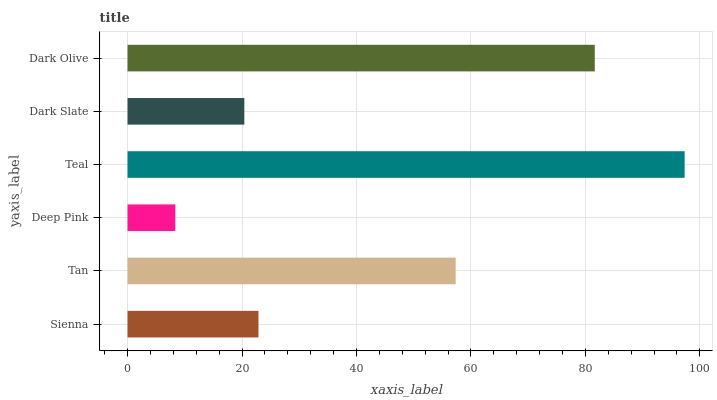Is Deep Pink the minimum?
Answer yes or no. Yes. Is Teal the maximum?
Answer yes or no. Yes. Is Tan the minimum?
Answer yes or no. No. Is Tan the maximum?
Answer yes or no. No. Is Tan greater than Sienna?
Answer yes or no. Yes. Is Sienna less than Tan?
Answer yes or no. Yes. Is Sienna greater than Tan?
Answer yes or no. No. Is Tan less than Sienna?
Answer yes or no. No. Is Tan the high median?
Answer yes or no. Yes. Is Sienna the low median?
Answer yes or no. Yes. Is Teal the high median?
Answer yes or no. No. Is Dark Olive the low median?
Answer yes or no. No. 